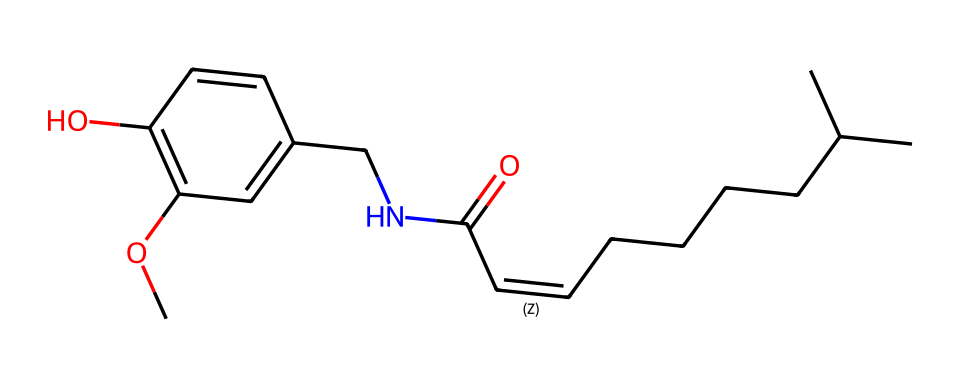What is the primary functional group in capsaicin? The structure shows an amide group, indicated by the presence of -C(=O)N- in the SMILES representation. This group is a characteristic of many alkaloids, including capsaicin.
Answer: amide How many carbon atoms are in the capsaicin molecule? By counting the carbon atoms from the structural formula represented in the SMILES, there are a total of 17 carbon atoms present in the molecule.
Answer: 17 What type of bonds connect the carbon atoms in capsaicin? The carbon atoms are primarily connected by single covalent bonds (evident from the structure) and one double bond, which is indicated by the "=" sign in the SMILES.
Answer: single and double bonds Which part of the molecule gives capsaicin its spiciness? The trans-alkene portion of the molecule, indicated by the double bond between carbon atoms, is responsible for the spicy flavor of capsaicin.
Answer: trans-alkene How many hydroxyl (-OH) groups are present in capsaicin? The structure includes one hydroxyl group, as seen by the -OH notation in the structural formula within the molecule.
Answer: one Is capsaicin classified as a polar or non-polar compound? The presence of the hydroxyl group and the amide functional group indicate that capsaicin has polar characteristics, while the longer hydrophobic carbon chain adds some non-polar aspects.
Answer: polar What biological activity does capsaicin exhibit due to its structure? The alkaloid nature and specific functional groups in capsaicin give it analgesic properties, allowing it to activate certain pain receptors while also providing a spicy taste.
Answer: analgesic 